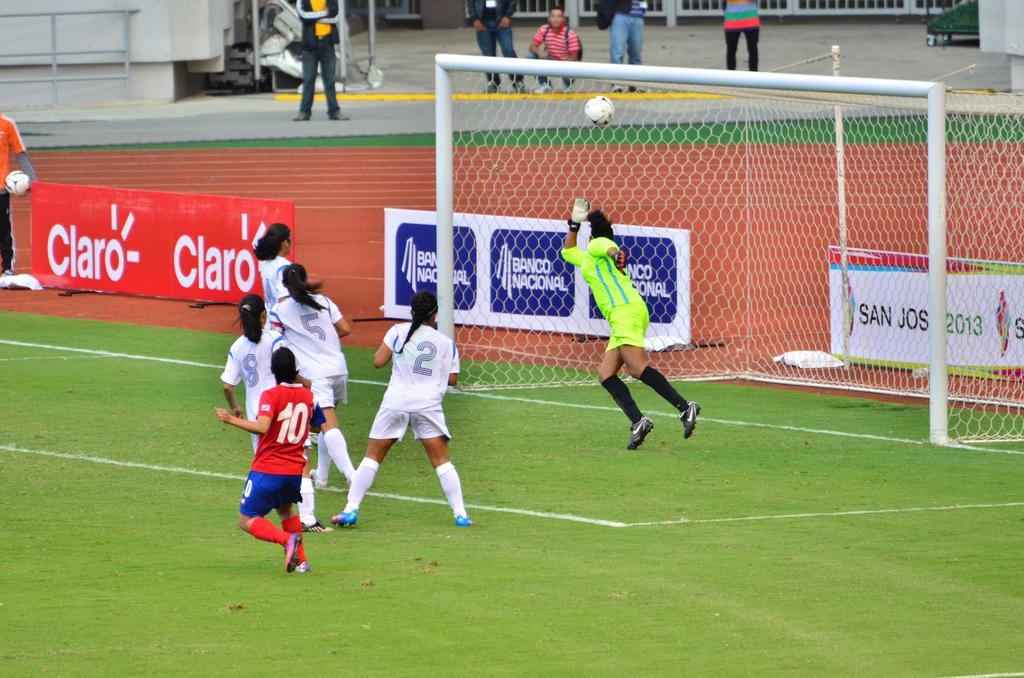In one or two sentences, can you explain what this image depicts? This picture is clicked outside. In the foreground we can see the group of persons wearing t-shirts and seems to be playing foot ball and we can see the ball which is in the air, we can see the net, metal rods, text on the banners, green grass. In the background we can see the group of persons and some other objects. 